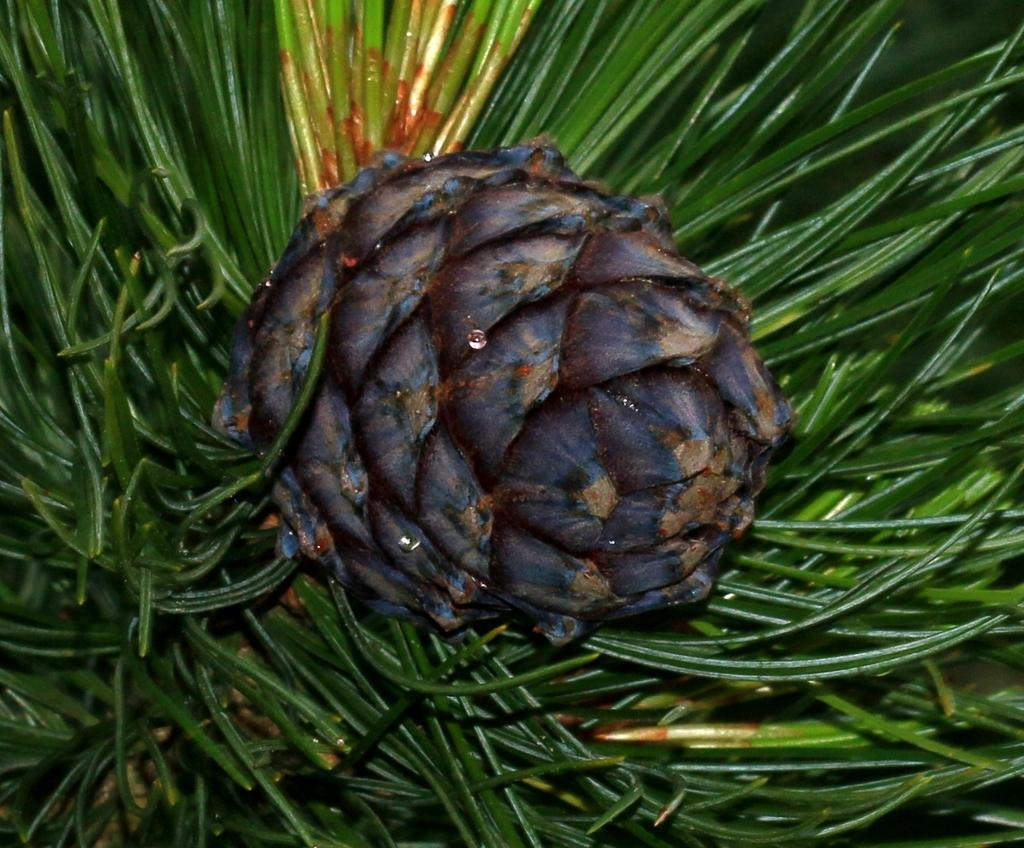What is present in the image? There is a plant in the image. What can be seen on the plant in the image? There is a fruit on the plant in the image. How many stars can be seen on the plant in the image? There are no stars present on the plant in the image. Is the plant located on a slope in the image? The image does not provide information about the slope or terrain where the plant is located. 